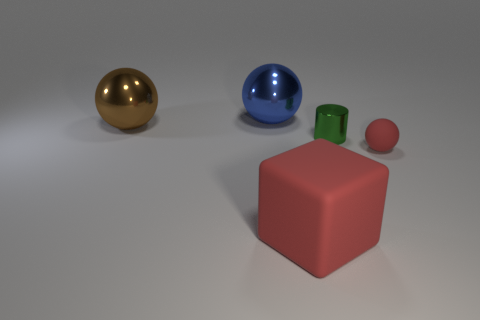Add 3 green cylinders. How many objects exist? 8 Subtract all cylinders. How many objects are left? 4 Subtract all small spheres. Subtract all big red cubes. How many objects are left? 3 Add 5 large blue metal things. How many large blue metal things are left? 6 Add 2 large blue objects. How many large blue objects exist? 3 Subtract 0 purple blocks. How many objects are left? 5 